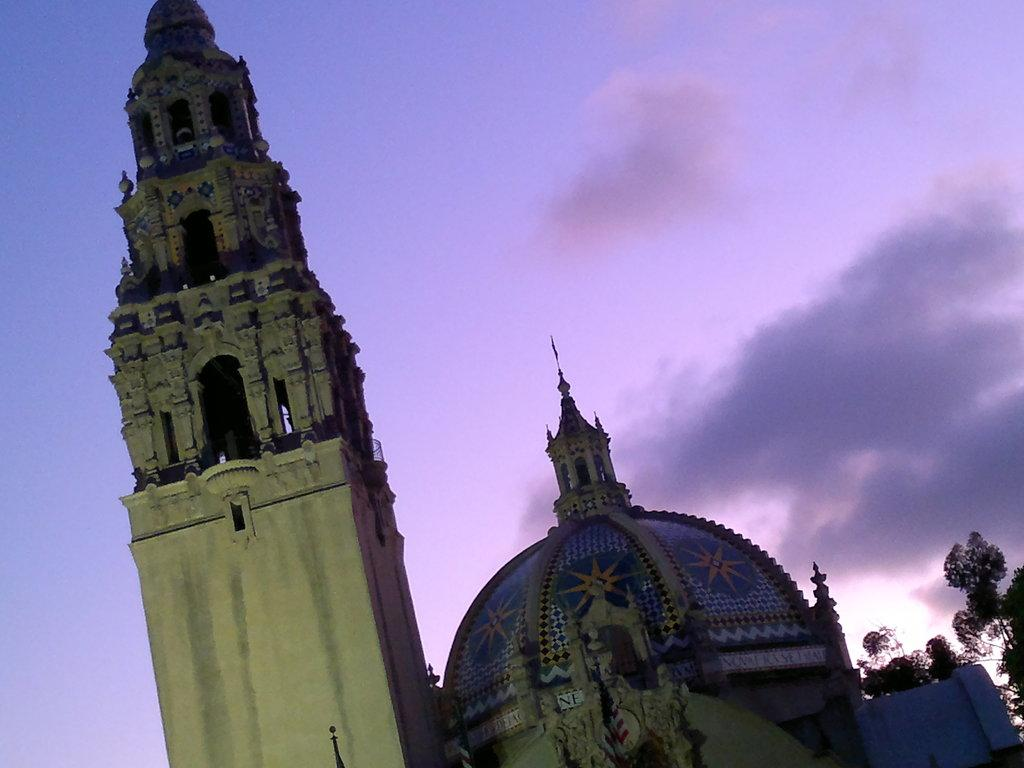What is the main structure visible in the image? There is a tower in the image. What other significant structure can be seen in the image? There is a tomb in the image. What type of vegetation is visible in the background of the image? There are trees in the background of the image. What is visible in the background of the image besides the trees? The sky is visible in the background of the image. What can be observed in the sky in the image? There are clouds in the sky. What type of scent can be smelled coming from the tower in the image? There is no indication of a scent in the image, as it is a visual representation and does not convey smells. 